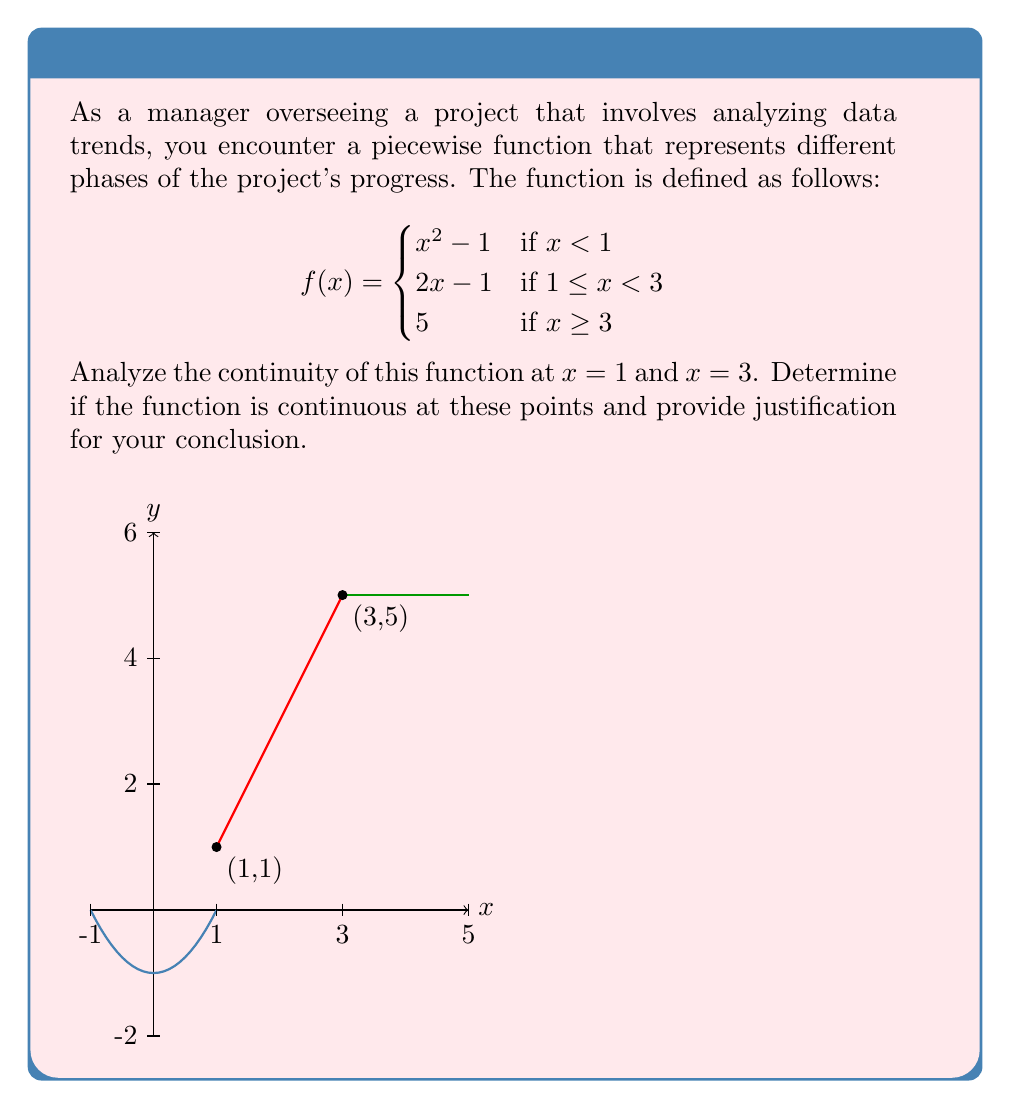Give your solution to this math problem. To analyze the continuity of the piecewise function at $x = 1$ and $x = 3$, we need to check three conditions at each point:

1. The function is defined at the point.
2. The limit of the function exists as we approach the point from both sides.
3. The limit equals the function value at that point.

For $x = 1$:

1. The function is defined at $x = 1$ (it's in the second piece of the function).
2. Let's check the limits:
   
   Left limit: $\lim_{x \to 1^-} (x^2 - 1) = 1^2 - 1 = 0$
   Right limit: $\lim_{x \to 1^+} (2x - 1) = 2(1) - 1 = 1$

   The left and right limits are not equal, so the limit doesn't exist at $x = 1$.

3. Since the limit doesn't exist, we don't need to check if it equals the function value.

Therefore, the function is not continuous at $x = 1$.

For $x = 3$:

1. The function is defined at $x = 3$ (it's in the third piece of the function).
2. Let's check the limits:
   
   Left limit: $\lim_{x \to 3^-} (2x - 1) = 2(3) - 1 = 5$
   Right limit: $\lim_{x \to 3^+} 5 = 5$

   The left and right limits are equal, so the limit exists and equals 5.

3. The function value at $x = 3$ is also 5.

Therefore, the function is continuous at $x = 3$.
Answer: The function is discontinuous at $x = 1$ and continuous at $x = 3$. 